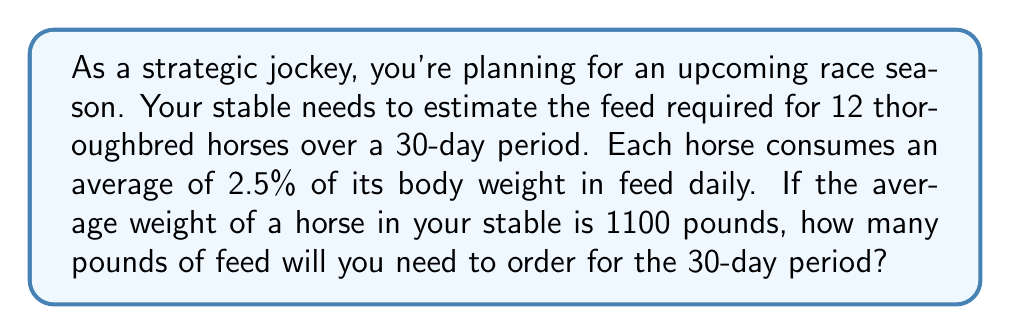Give your solution to this math problem. Let's break this down step-by-step:

1) First, calculate the daily feed consumption for one horse:
   $\text{Daily feed} = 2.5\% \times 1100 \text{ pounds}$
   $\text{Daily feed} = 0.025 \times 1100 = 27.5 \text{ pounds}$

2) Now, calculate the feed consumption for one horse over 30 days:
   $\text{30-day feed per horse} = 27.5 \text{ pounds} \times 30 \text{ days} = 825 \text{ pounds}$

3) Finally, calculate the total feed needed for all 12 horses over 30 days:
   $\text{Total feed} = 825 \text{ pounds} \times 12 \text{ horses} = 9900 \text{ pounds}$

Therefore, you will need to order 9900 pounds of feed for the 30-day period.
Answer: 9900 pounds 